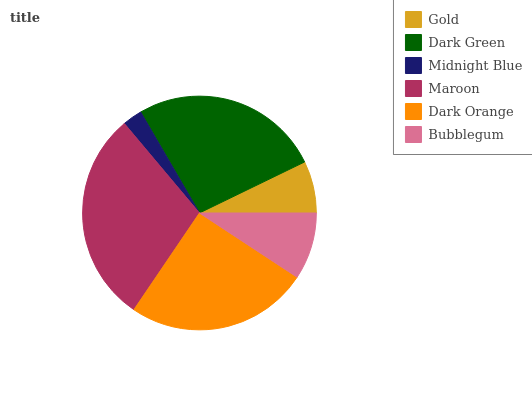Is Midnight Blue the minimum?
Answer yes or no. Yes. Is Maroon the maximum?
Answer yes or no. Yes. Is Dark Green the minimum?
Answer yes or no. No. Is Dark Green the maximum?
Answer yes or no. No. Is Dark Green greater than Gold?
Answer yes or no. Yes. Is Gold less than Dark Green?
Answer yes or no. Yes. Is Gold greater than Dark Green?
Answer yes or no. No. Is Dark Green less than Gold?
Answer yes or no. No. Is Dark Orange the high median?
Answer yes or no. Yes. Is Bubblegum the low median?
Answer yes or no. Yes. Is Gold the high median?
Answer yes or no. No. Is Dark Orange the low median?
Answer yes or no. No. 